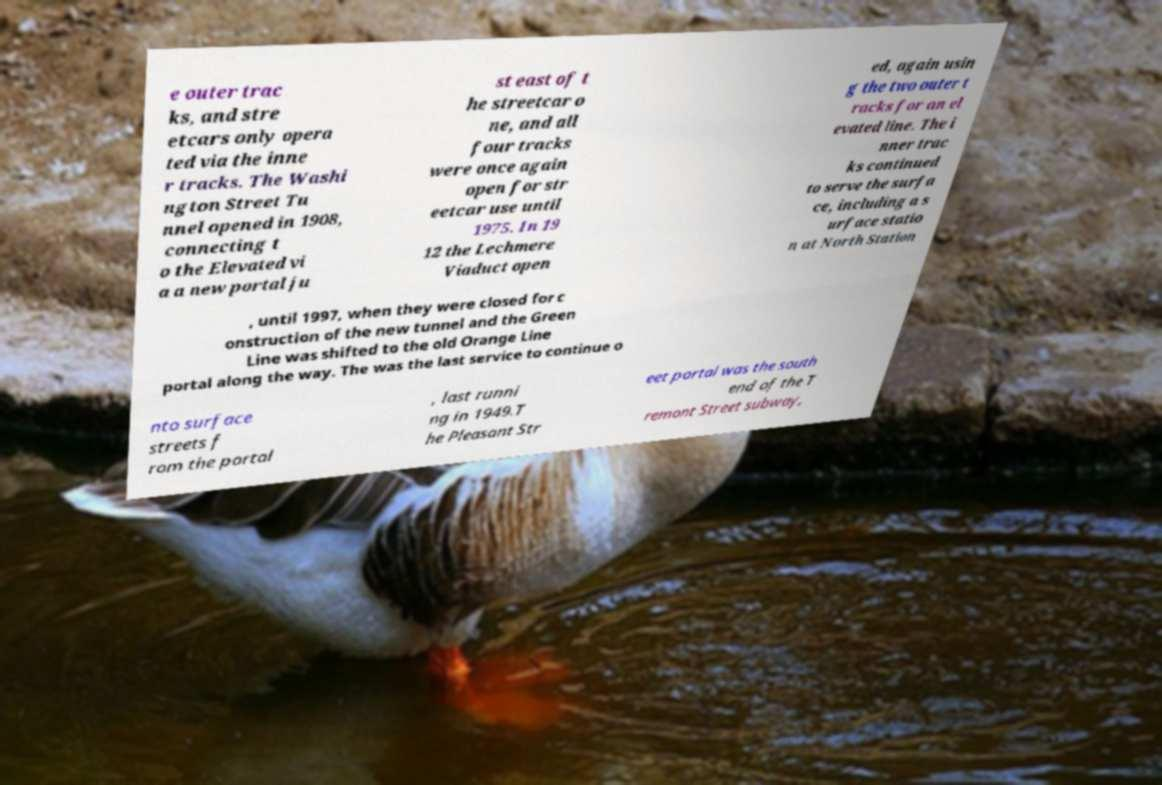Please read and relay the text visible in this image. What does it say? e outer trac ks, and stre etcars only opera ted via the inne r tracks. The Washi ngton Street Tu nnel opened in 1908, connecting t o the Elevated vi a a new portal ju st east of t he streetcar o ne, and all four tracks were once again open for str eetcar use until 1975. In 19 12 the Lechmere Viaduct open ed, again usin g the two outer t racks for an el evated line. The i nner trac ks continued to serve the surfa ce, including a s urface statio n at North Station , until 1997, when they were closed for c onstruction of the new tunnel and the Green Line was shifted to the old Orange Line portal along the way. The was the last service to continue o nto surface streets f rom the portal , last runni ng in 1949.T he Pleasant Str eet portal was the south end of the T remont Street subway, 